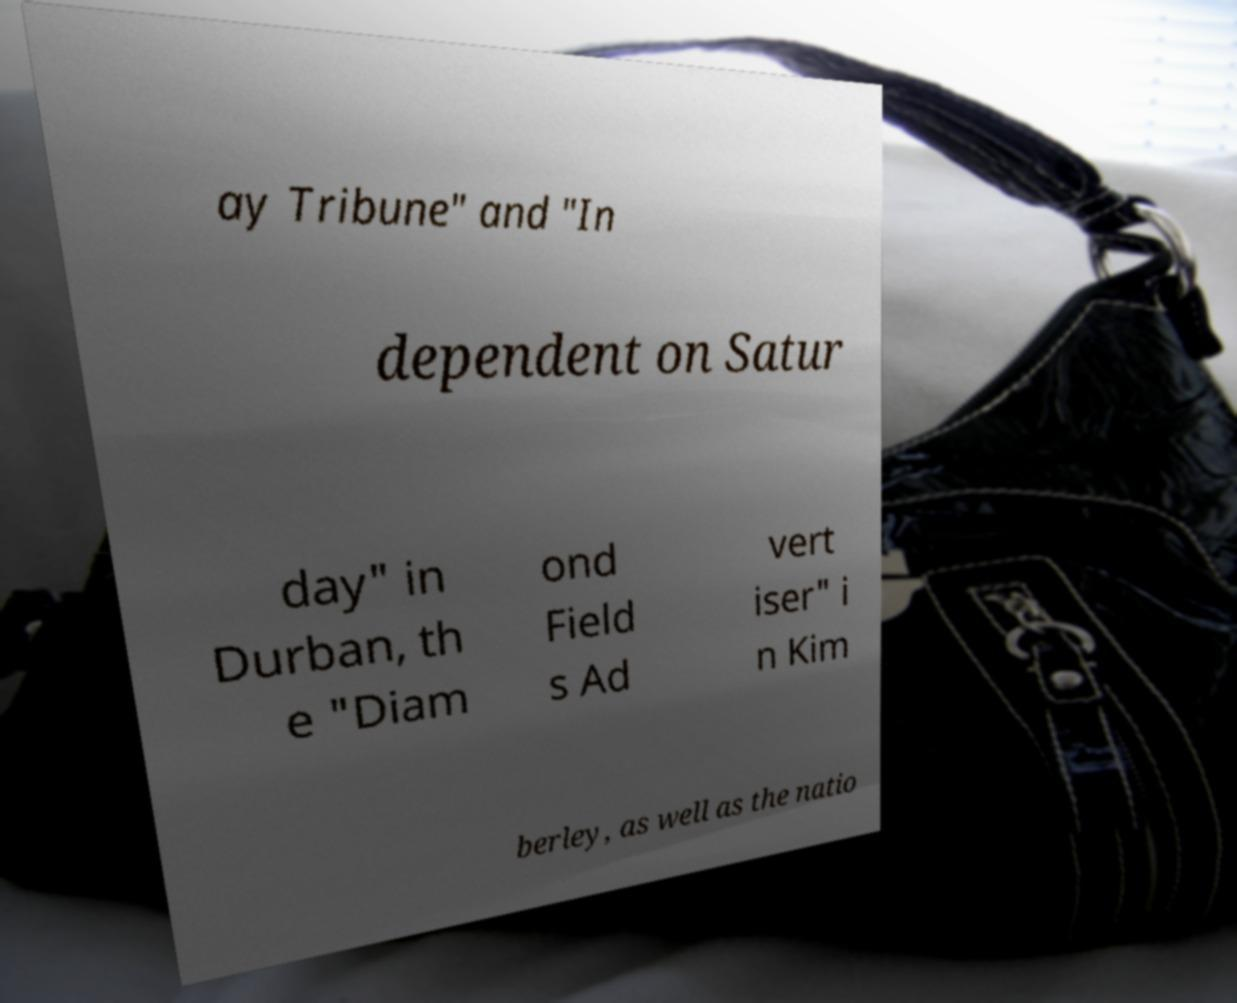There's text embedded in this image that I need extracted. Can you transcribe it verbatim? ay Tribune" and "In dependent on Satur day" in Durban, th e "Diam ond Field s Ad vert iser" i n Kim berley, as well as the natio 